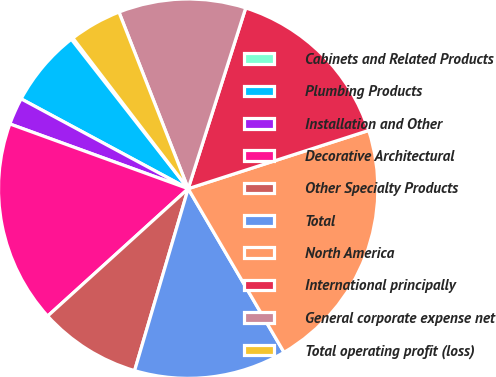<chart> <loc_0><loc_0><loc_500><loc_500><pie_chart><fcel>Cabinets and Related Products<fcel>Plumbing Products<fcel>Installation and Other<fcel>Decorative Architectural<fcel>Other Specialty Products<fcel>Total<fcel>North America<fcel>International principally<fcel>General corporate expense net<fcel>Total operating profit (loss)<nl><fcel>0.17%<fcel>6.58%<fcel>2.31%<fcel>17.26%<fcel>8.72%<fcel>12.99%<fcel>21.53%<fcel>15.13%<fcel>10.85%<fcel>4.45%<nl></chart> 